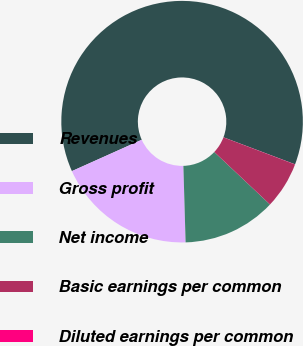<chart> <loc_0><loc_0><loc_500><loc_500><pie_chart><fcel>Revenues<fcel>Gross profit<fcel>Net income<fcel>Basic earnings per common<fcel>Diluted earnings per common<nl><fcel>62.46%<fcel>18.75%<fcel>12.51%<fcel>6.26%<fcel>0.02%<nl></chart> 